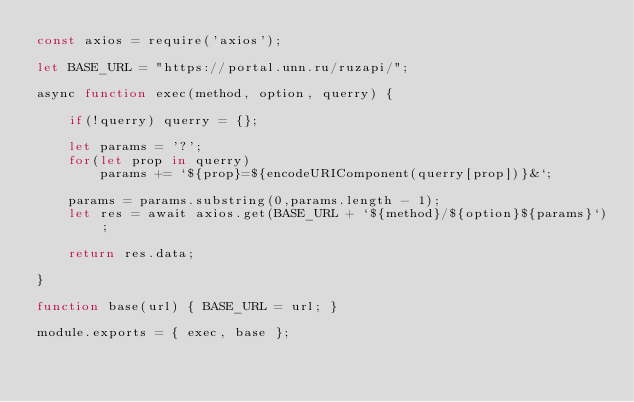<code> <loc_0><loc_0><loc_500><loc_500><_JavaScript_>const axios = require('axios');

let BASE_URL = "https://portal.unn.ru/ruzapi/";

async function exec(method, option, querry) {

    if(!querry) querry = {};

    let params = '?';
    for(let prop in querry)
        params += `${prop}=${encodeURIComponent(querry[prop])}&`;    
    
    params = params.substring(0,params.length - 1);
    let res = await axios.get(BASE_URL + `${method}/${option}${params}`);

    return res.data;

}

function base(url) { BASE_URL = url; }

module.exports = { exec, base };</code> 